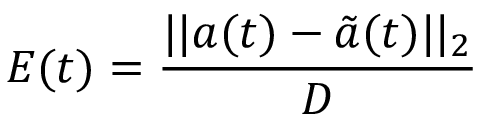Convert formula to latex. <formula><loc_0><loc_0><loc_500><loc_500>E ( t ) = \frac { | | a ( t ) - \tilde { a } ( t ) | | _ { 2 } } { D }</formula> 